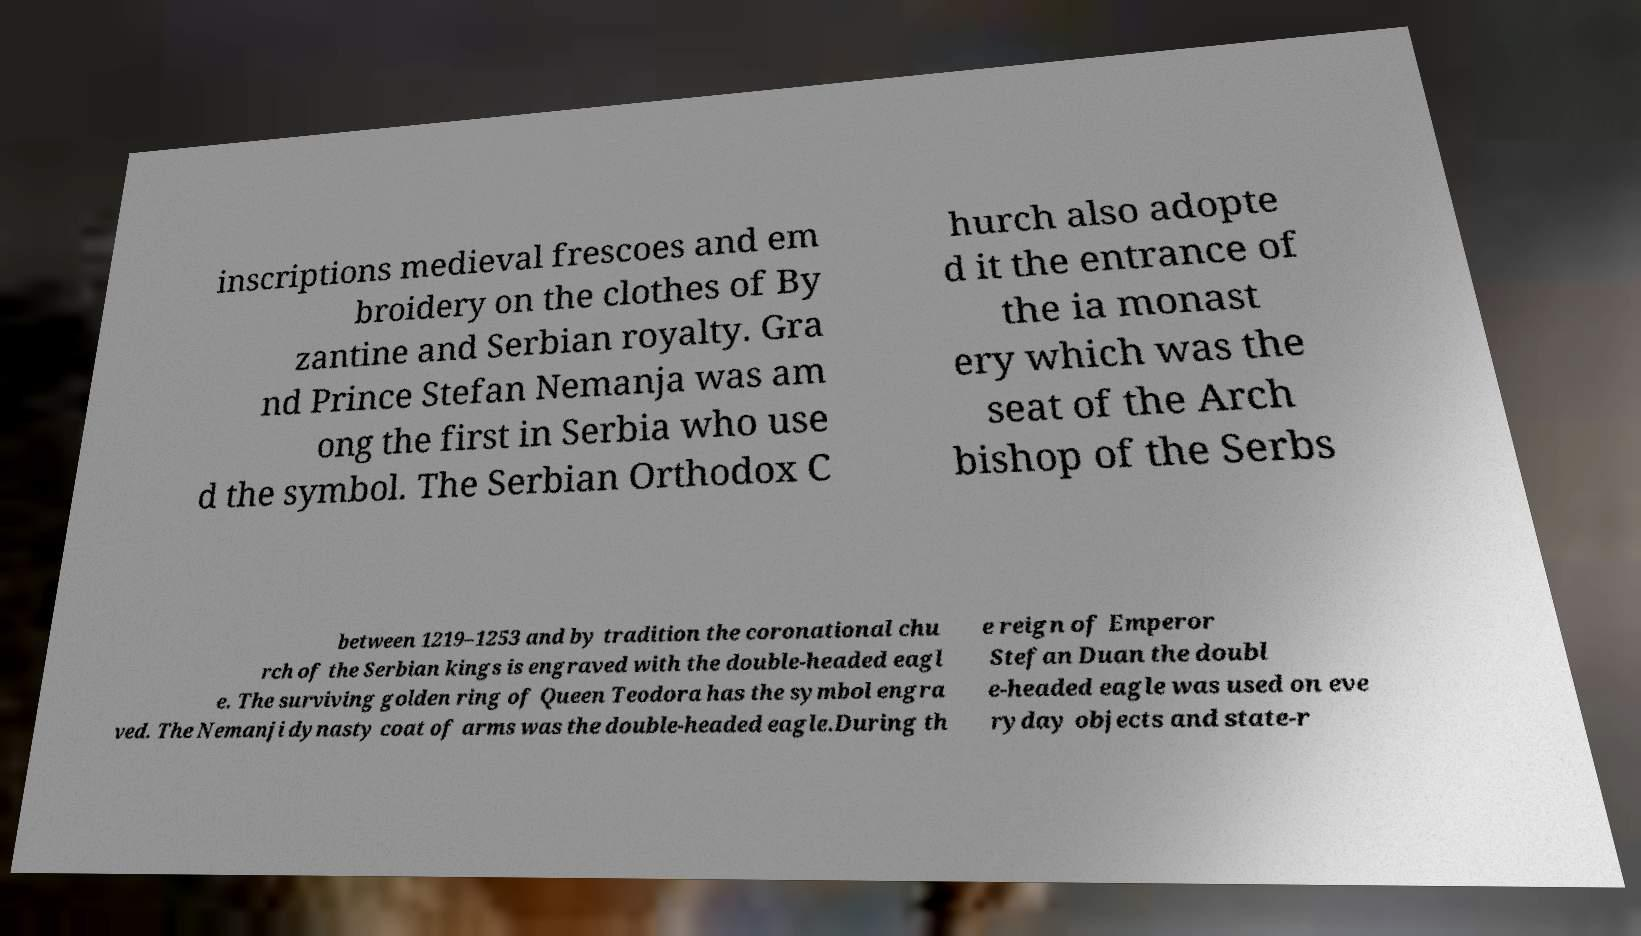Could you extract and type out the text from this image? inscriptions medieval frescoes and em broidery on the clothes of By zantine and Serbian royalty. Gra nd Prince Stefan Nemanja was am ong the first in Serbia who use d the symbol. The Serbian Orthodox C hurch also adopte d it the entrance of the ia monast ery which was the seat of the Arch bishop of the Serbs between 1219–1253 and by tradition the coronational chu rch of the Serbian kings is engraved with the double-headed eagl e. The surviving golden ring of Queen Teodora has the symbol engra ved. The Nemanji dynasty coat of arms was the double-headed eagle.During th e reign of Emperor Stefan Duan the doubl e-headed eagle was used on eve ryday objects and state-r 